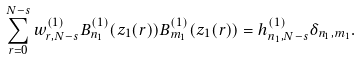<formula> <loc_0><loc_0><loc_500><loc_500>\sum _ { r = 0 } ^ { N - s } w ^ { ( 1 ) } _ { r , N - s } B _ { n _ { 1 } } ^ { ( 1 ) } ( z _ { 1 } ( r ) ) B _ { m _ { 1 } } ^ { ( 1 ) } ( z _ { 1 } ( r ) ) = h _ { n _ { 1 } , N - s } ^ { ( 1 ) } \delta _ { n _ { 1 } , m _ { 1 } } .</formula> 